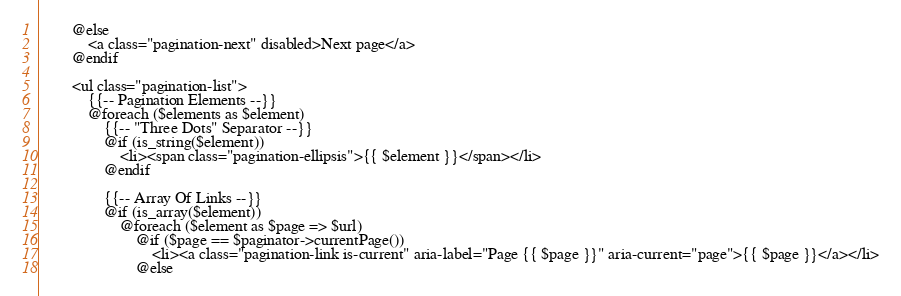<code> <loc_0><loc_0><loc_500><loc_500><_PHP_>        @else
            <a class="pagination-next" disabled>Next page</a>
        @endif

        <ul class="pagination-list">
            {{-- Pagination Elements --}}
            @foreach ($elements as $element)
                {{-- "Three Dots" Separator --}}
                @if (is_string($element))
                    <li><span class="pagination-ellipsis">{{ $element }}</span></li>
                @endif

                {{-- Array Of Links --}}
                @if (is_array($element))
                    @foreach ($element as $page => $url)
                        @if ($page == $paginator->currentPage())
                            <li><a class="pagination-link is-current" aria-label="Page {{ $page }}" aria-current="page">{{ $page }}</a></li>
                        @else</code> 